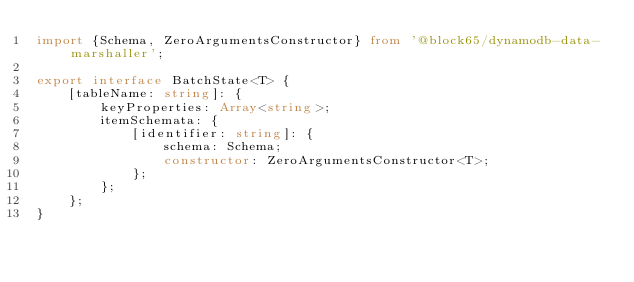<code> <loc_0><loc_0><loc_500><loc_500><_TypeScript_>import {Schema, ZeroArgumentsConstructor} from '@block65/dynamodb-data-marshaller';

export interface BatchState<T> {
    [tableName: string]: {
        keyProperties: Array<string>;
        itemSchemata: {
            [identifier: string]: {
                schema: Schema;
                constructor: ZeroArgumentsConstructor<T>;
            };
        };
    };
}
</code> 